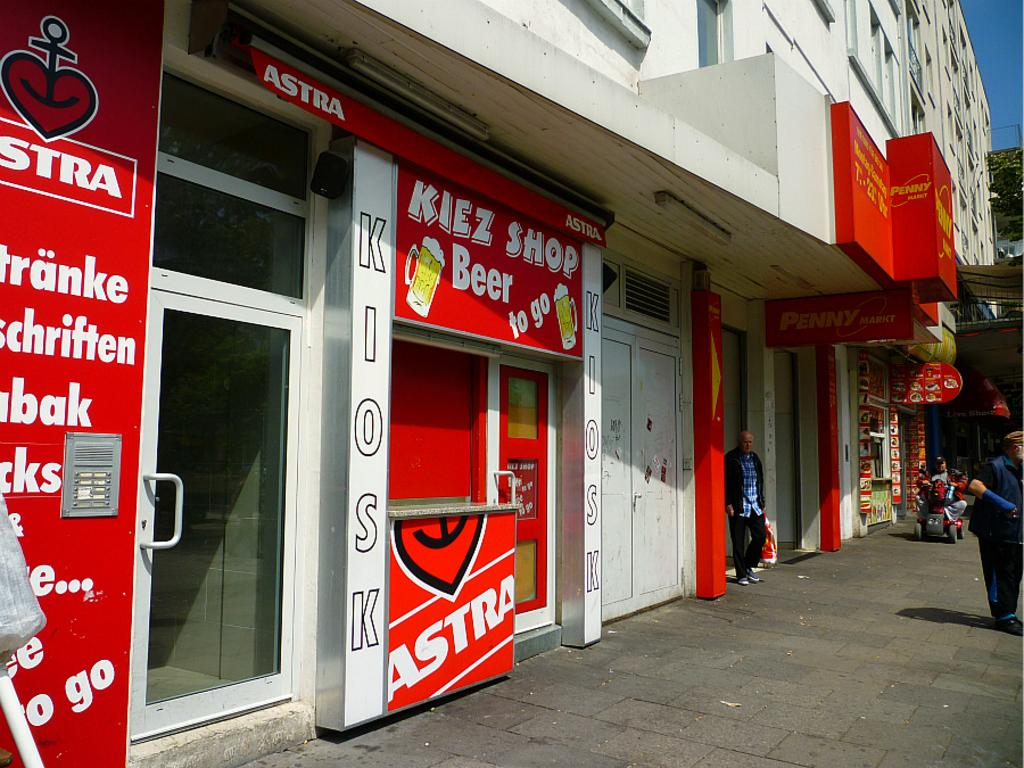What type of structures can be seen in the image? There are buildings in the image. What else can be found in the image besides buildings? There are stalls in the image. Can you describe the people in the image? Two persons are standing in front of a building, and there is a person sitting in a vehicle. What type of base can be seen supporting the cattle in the image? There are no cattle present in the image, so there is no base supporting them. 